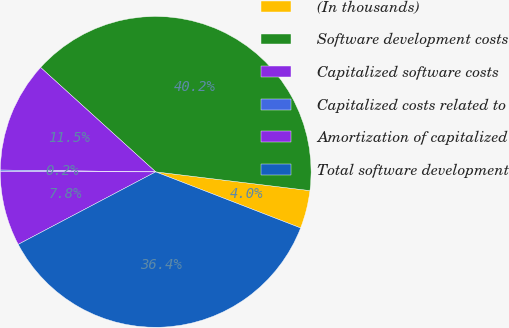<chart> <loc_0><loc_0><loc_500><loc_500><pie_chart><fcel>(In thousands)<fcel>Software development costs<fcel>Capitalized software costs<fcel>Capitalized costs related to<fcel>Amortization of capitalized<fcel>Total software development<nl><fcel>3.95%<fcel>40.2%<fcel>11.54%<fcel>0.16%<fcel>7.75%<fcel>36.4%<nl></chart> 